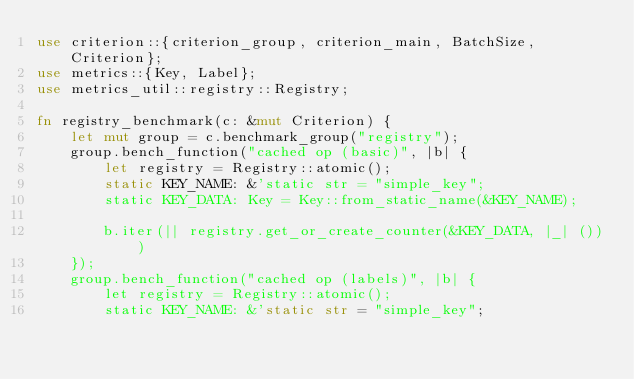<code> <loc_0><loc_0><loc_500><loc_500><_Rust_>use criterion::{criterion_group, criterion_main, BatchSize, Criterion};
use metrics::{Key, Label};
use metrics_util::registry::Registry;

fn registry_benchmark(c: &mut Criterion) {
    let mut group = c.benchmark_group("registry");
    group.bench_function("cached op (basic)", |b| {
        let registry = Registry::atomic();
        static KEY_NAME: &'static str = "simple_key";
        static KEY_DATA: Key = Key::from_static_name(&KEY_NAME);

        b.iter(|| registry.get_or_create_counter(&KEY_DATA, |_| ()))
    });
    group.bench_function("cached op (labels)", |b| {
        let registry = Registry::atomic();
        static KEY_NAME: &'static str = "simple_key";</code> 